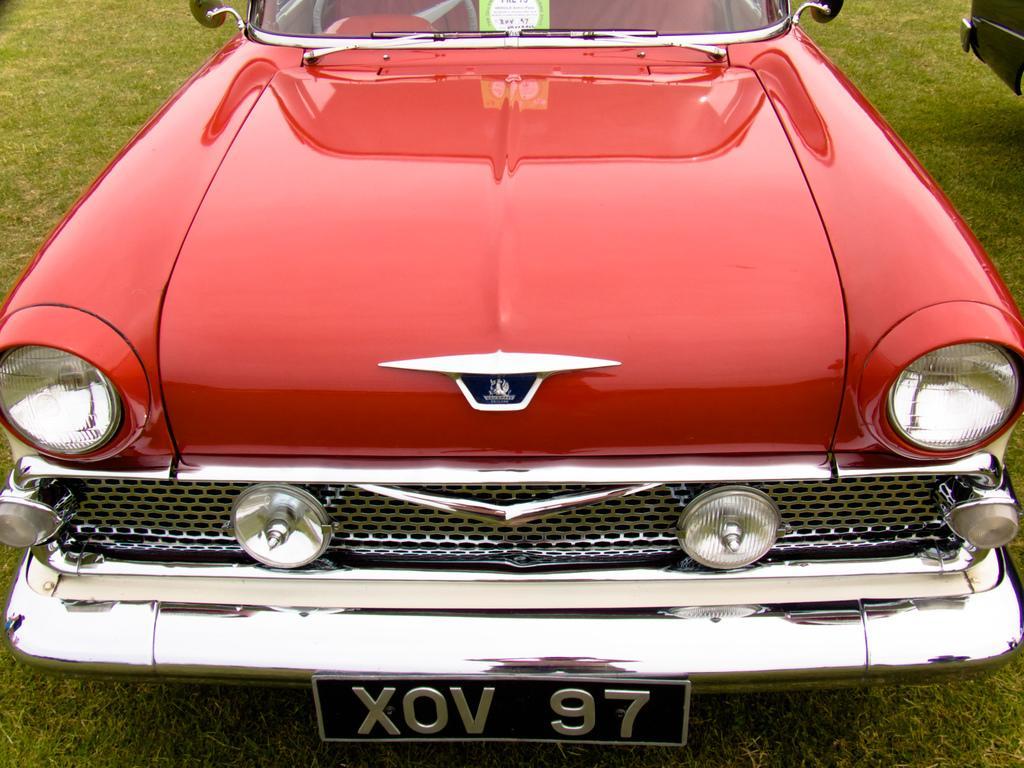Could you give a brief overview of what you see in this image? In the center of the image we can see one car, which is in a red color. On the car, there is a logo, number plate and one paper on the glass. At the top right side of the image, we can see one object. In the background, we can see the grass. 